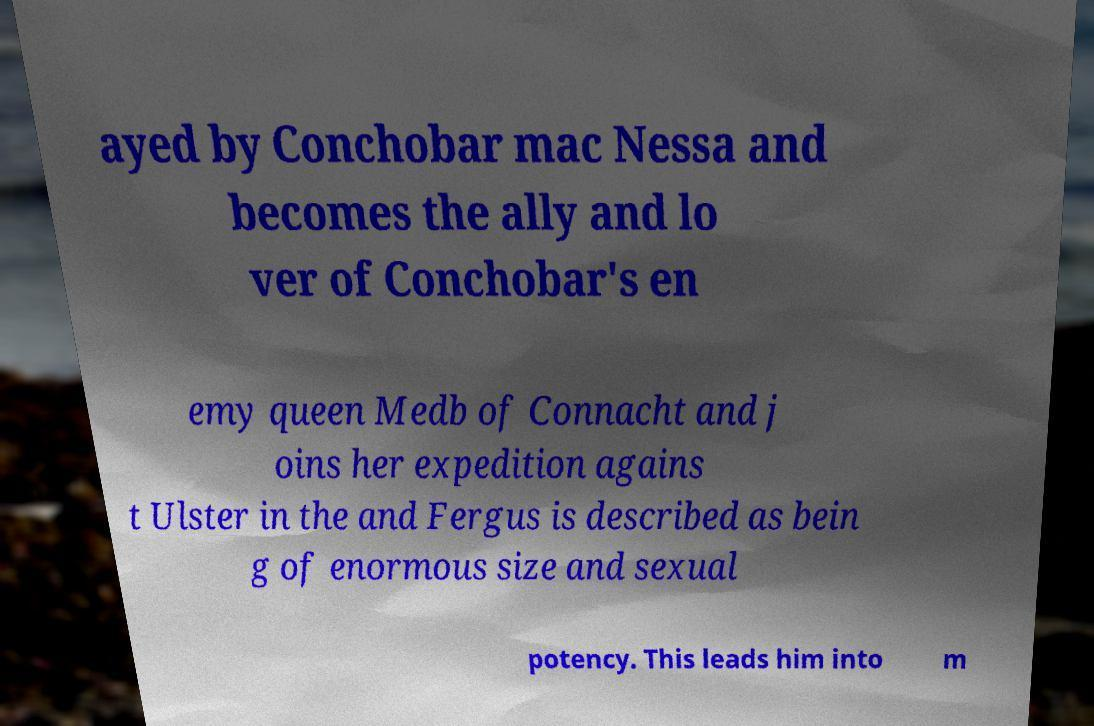I need the written content from this picture converted into text. Can you do that? ayed by Conchobar mac Nessa and becomes the ally and lo ver of Conchobar's en emy queen Medb of Connacht and j oins her expedition agains t Ulster in the and Fergus is described as bein g of enormous size and sexual potency. This leads him into m 